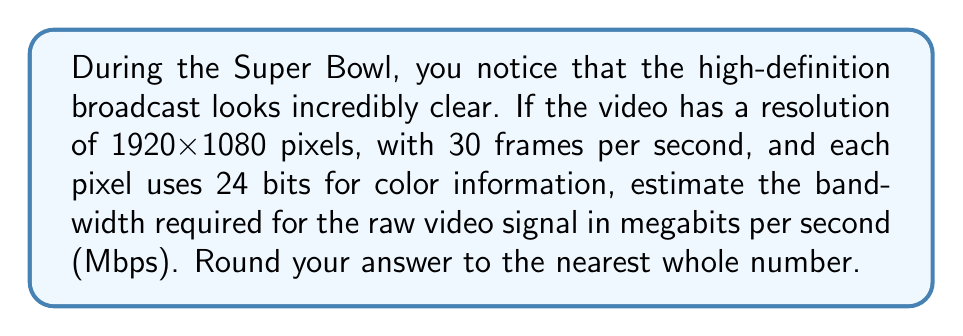What is the answer to this math problem? To estimate the bandwidth required for the high-definition Super Bowl broadcast, we need to calculate the amount of data transmitted per second. Let's break this down step-by-step:

1. Calculate the number of pixels per frame:
   $$ \text{Pixels per frame} = 1920 \times 1080 = 2,073,600 \text{ pixels} $$

2. Calculate the number of bits per pixel:
   Each pixel uses 24 bits for color information.

3. Calculate the number of bits per frame:
   $$ \text{Bits per frame} = 2,073,600 \times 24 = 49,766,400 \text{ bits} $$

4. Calculate the number of frames per second:
   The video has 30 frames per second.

5. Calculate the total number of bits per second:
   $$ \text{Bits per second} = 49,766,400 \times 30 = 1,492,992,000 \text{ bits/s} $$

6. Convert bits per second to megabits per second:
   $$ \text{Mbps} = \frac{1,492,992,000}{1,000,000} = 1492.992 \text{ Mbps} $$

7. Round to the nearest whole number:
   1492.992 Mbps rounds to 1493 Mbps.
Answer: 1493 Mbps 